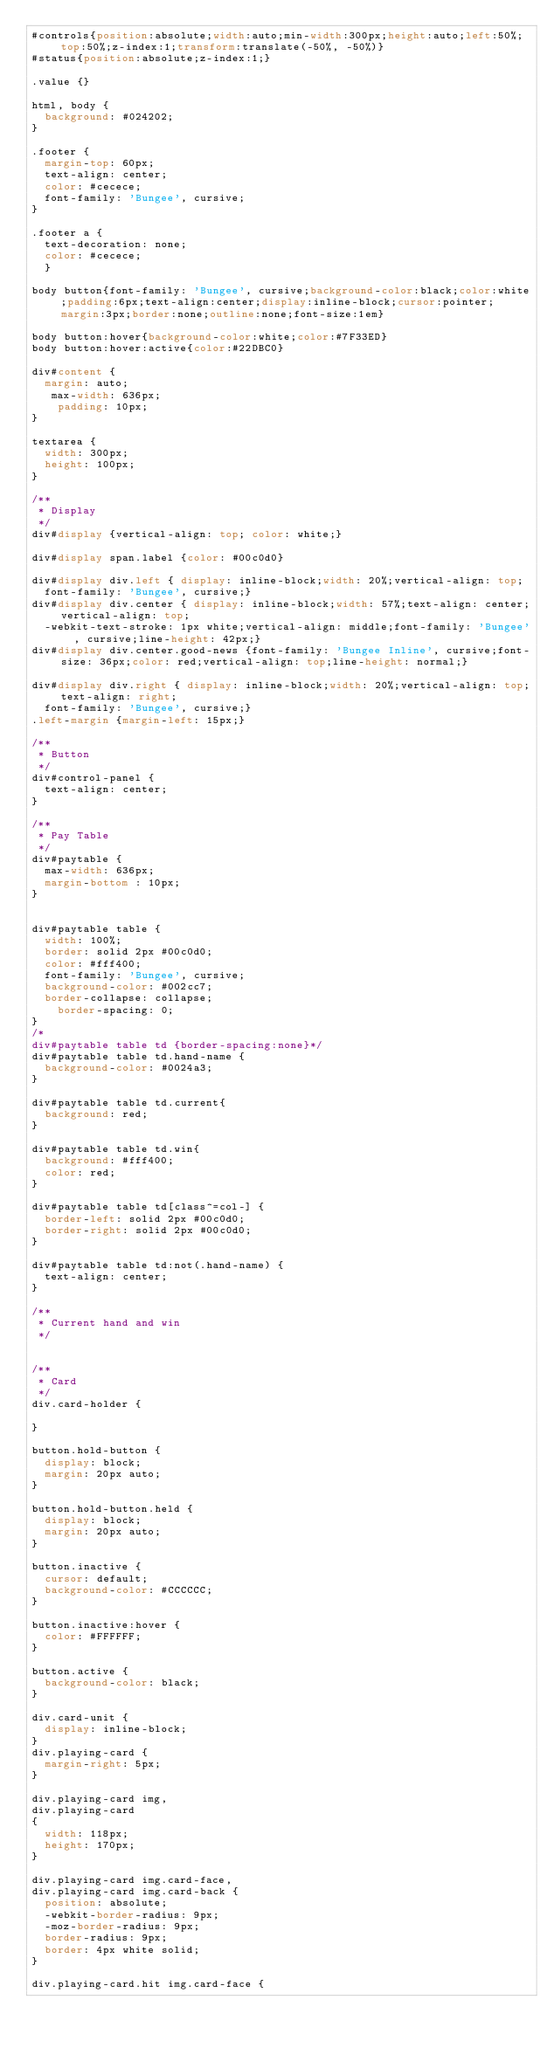Convert code to text. <code><loc_0><loc_0><loc_500><loc_500><_CSS_>#controls{position:absolute;width:auto;min-width:300px;height:auto;left:50%;top:50%;z-index:1;transform:translate(-50%, -50%)}
#status{position:absolute;z-index:1;}

.value {}

html, body {
	background: #024202;
}

.footer {
	margin-top: 60px;
	text-align: center;
	color: #cecece;
	font-family: 'Bungee', cursive;
}

.footer a {
	text-decoration: none;
	color: #cecece;
	}

body button{font-family: 'Bungee', cursive;background-color:black;color:white;padding:6px;text-align:center;display:inline-block;cursor:pointer;margin:3px;border:none;outline:none;font-size:1em}

body button:hover{background-color:white;color:#7F33ED}
body button:hover:active{color:#22DBC0}

div#content {
	margin: auto;
   max-width: 636px;
    padding: 10px;
}

textarea {
	width: 300px;
	height: 100px;
}

/**
 * Display
 */
div#display {vertical-align: top; color: white;}

div#display span.label {color: #00c0d0}

div#display div.left { display: inline-block;width: 20%;vertical-align: top;
	font-family: 'Bungee', cursive;}
div#display div.center { display: inline-block;width: 57%;text-align: center;vertical-align: top;
	-webkit-text-stroke: 1px white;vertical-align: middle;font-family: 'Bungee', cursive;line-height: 42px;}
div#display div.center.good-news {font-family: 'Bungee Inline', cursive;font-size: 36px;color: red;vertical-align: top;line-height: normal;}

div#display div.right { display: inline-block;width: 20%;vertical-align: top;text-align: right;
	font-family: 'Bungee', cursive;}
.left-margin {margin-left: 15px;}

/**
 * Button
 */
div#control-panel {
	text-align: center;
}

/**
 * Pay Table
 */
div#paytable {
	max-width: 636px;
	margin-bottom : 10px;
}


div#paytable table {
	width: 100%;
	border: solid 2px #00c0d0;
	color: #fff400;
	font-family: 'Bungee', cursive;
	background-color: #002cc7;
	border-collapse: collapse;
    border-spacing: 0;
}
/*
div#paytable table td {border-spacing:none}*/
div#paytable table td.hand-name {
	background-color: #0024a3;
}

div#paytable table td.current{
	background: red;
}

div#paytable table td.win{
	background: #fff400;
	color: red;
}

div#paytable table td[class^=col-] {
	border-left: solid 2px #00c0d0;
	border-right: solid 2px #00c0d0;
}

div#paytable table td:not(.hand-name) {
	text-align: center;
}

/**
 * Current hand and win
 */


/**
 * Card
 */
div.card-holder {

}

button.hold-button {
	display: block;
	margin: 20px auto;
}

button.hold-button.held {
	display: block;
	margin: 20px auto;
}

button.inactive {
	cursor: default;
	background-color: #CCCCCC;
}

button.inactive:hover {
	color: #FFFFFF;
}

button.active {
	background-color: black;
}

div.card-unit {
	display: inline-block;
}
div.playing-card {
	margin-right: 5px;
}

div.playing-card img,
div.playing-card
{
	width: 118px;
	height: 170px;
}

div.playing-card img.card-face,
div.playing-card img.card-back {
	position: absolute;
	-webkit-border-radius: 9px;
	-moz-border-radius: 9px;
	border-radius: 9px;
	border: 4px white solid;
}

div.playing-card.hit img.card-face {</code> 